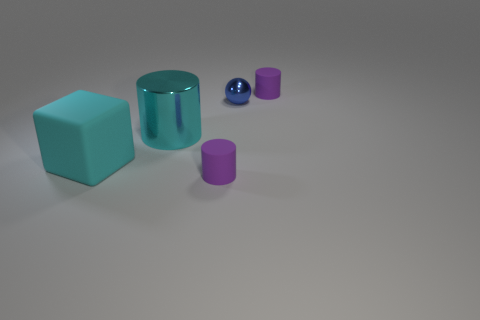Is there a small matte cylinder in front of the big cyan thing that is right of the large rubber object?
Give a very brief answer. Yes. Is there a purple rubber thing that has the same shape as the big cyan metallic object?
Offer a terse response. Yes. Do the large matte thing and the big metallic object have the same color?
Offer a very short reply. Yes. There is a cyan cylinder that is on the left side of the tiny cylinder that is behind the big metallic thing; what is its material?
Keep it short and to the point. Metal. The cyan metallic thing is what size?
Your response must be concise. Large. The cyan cylinder that is the same material as the small blue thing is what size?
Make the answer very short. Large. Do the purple rubber thing on the right side of the blue shiny thing and the big cyan rubber block have the same size?
Your response must be concise. No. There is a shiny thing to the right of the small cylinder that is in front of the purple cylinder that is behind the metallic cylinder; what shape is it?
Give a very brief answer. Sphere. How many objects are either small purple things or purple cylinders right of the blue metal ball?
Your response must be concise. 2. What is the size of the purple cylinder that is in front of the small metal object?
Your answer should be very brief. Small. 